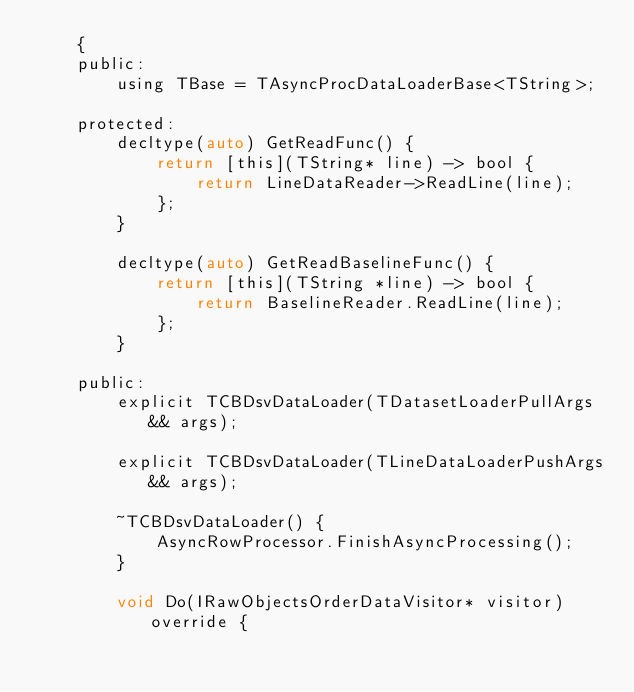<code> <loc_0><loc_0><loc_500><loc_500><_C_>    {
    public:
        using TBase = TAsyncProcDataLoaderBase<TString>;

    protected:
        decltype(auto) GetReadFunc() {
            return [this](TString* line) -> bool {
                return LineDataReader->ReadLine(line);
            };
        }

        decltype(auto) GetReadBaselineFunc() {
            return [this](TString *line) -> bool {
                return BaselineReader.ReadLine(line);
            };
        }

    public:
        explicit TCBDsvDataLoader(TDatasetLoaderPullArgs&& args);

        explicit TCBDsvDataLoader(TLineDataLoaderPushArgs&& args);

        ~TCBDsvDataLoader() {
            AsyncRowProcessor.FinishAsyncProcessing();
        }

        void Do(IRawObjectsOrderDataVisitor* visitor) override {</code> 